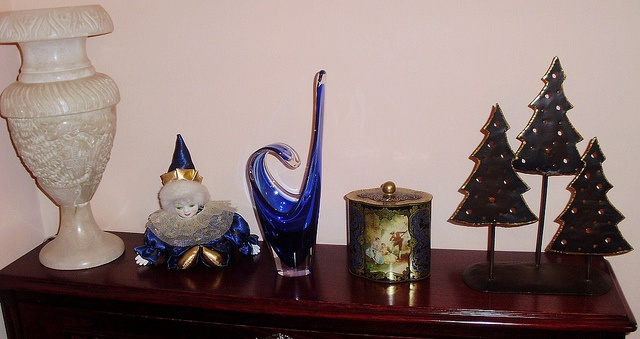Describe the objects in this image and their specific colors. I can see vase in tan, darkgray, and gray tones and vase in tan, black, navy, darkblue, and blue tones in this image. 